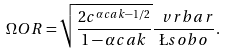<formula> <loc_0><loc_0><loc_500><loc_500>\Omega O R = \sqrt { \frac { 2 c ^ { \alpha c a k - 1 / 2 } } { 1 - \alpha c a k } } \frac { \ v r b a r } { \L s o b o } .</formula> 